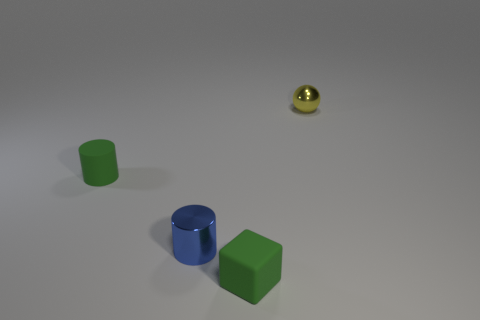If you were to relate these objects to musical instruments, which instruments would they each resemble and why? If we were to liken these objects to musical instruments, the green cube could be seen as a drum, providing a solid, steady base. The cylindrical shapes might represent wind instruments; the blue one could be akin to a flute with its slender form, while the green cylinder might resemble a brass instrument with a wider body, like a tuba. The tiny yellow sphere, with its bright and distinct presence, could be compared to a bell or a high-pitched percussion instrument, adding a sharp punctuation to the ensemble. 